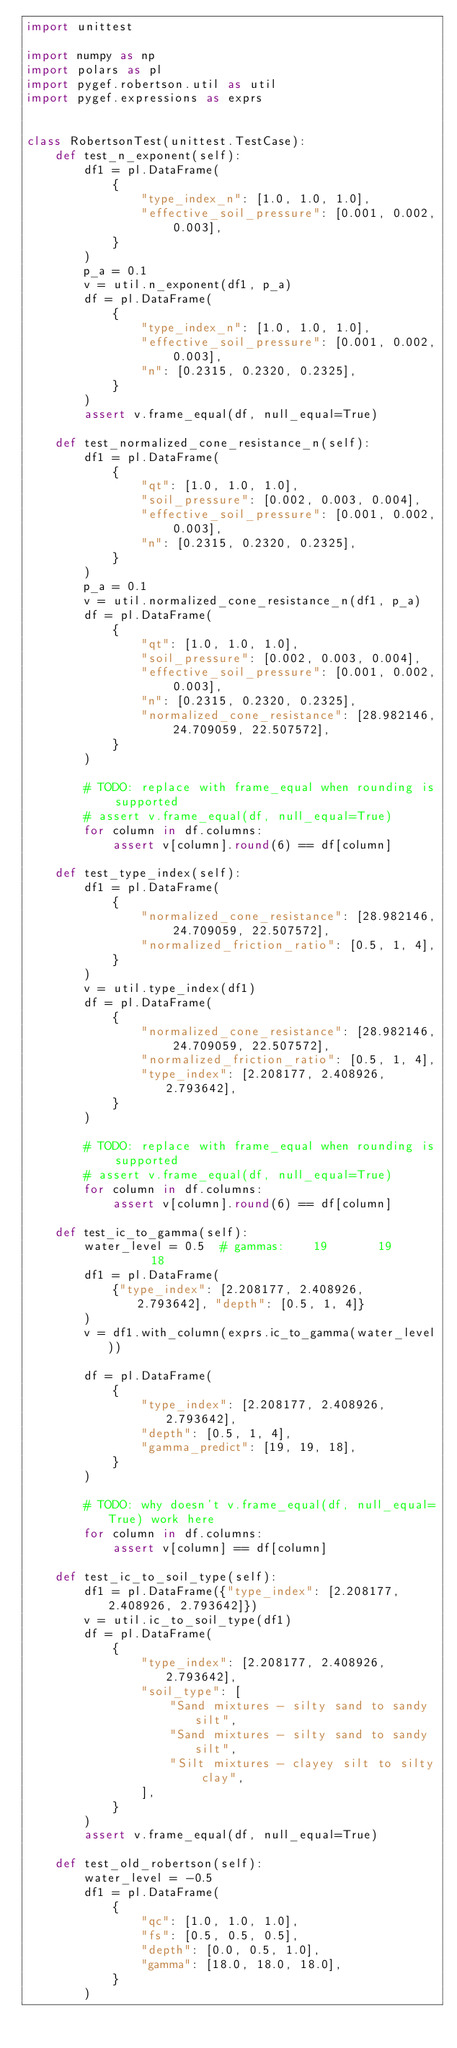Convert code to text. <code><loc_0><loc_0><loc_500><loc_500><_Python_>import unittest

import numpy as np
import polars as pl
import pygef.robertson.util as util
import pygef.expressions as exprs


class RobertsonTest(unittest.TestCase):
    def test_n_exponent(self):
        df1 = pl.DataFrame(
            {
                "type_index_n": [1.0, 1.0, 1.0],
                "effective_soil_pressure": [0.001, 0.002, 0.003],
            }
        )
        p_a = 0.1
        v = util.n_exponent(df1, p_a)
        df = pl.DataFrame(
            {
                "type_index_n": [1.0, 1.0, 1.0],
                "effective_soil_pressure": [0.001, 0.002, 0.003],
                "n": [0.2315, 0.2320, 0.2325],
            }
        )
        assert v.frame_equal(df, null_equal=True)

    def test_normalized_cone_resistance_n(self):
        df1 = pl.DataFrame(
            {
                "qt": [1.0, 1.0, 1.0],
                "soil_pressure": [0.002, 0.003, 0.004],
                "effective_soil_pressure": [0.001, 0.002, 0.003],
                "n": [0.2315, 0.2320, 0.2325],
            }
        )
        p_a = 0.1
        v = util.normalized_cone_resistance_n(df1, p_a)
        df = pl.DataFrame(
            {
                "qt": [1.0, 1.0, 1.0],
                "soil_pressure": [0.002, 0.003, 0.004],
                "effective_soil_pressure": [0.001, 0.002, 0.003],
                "n": [0.2315, 0.2320, 0.2325],
                "normalized_cone_resistance": [28.982146, 24.709059, 22.507572],
            }
        )

        # TODO: replace with frame_equal when rounding is supported
        # assert v.frame_equal(df, null_equal=True)
        for column in df.columns:
            assert v[column].round(6) == df[column]

    def test_type_index(self):
        df1 = pl.DataFrame(
            {
                "normalized_cone_resistance": [28.982146, 24.709059, 22.507572],
                "normalized_friction_ratio": [0.5, 1, 4],
            }
        )
        v = util.type_index(df1)
        df = pl.DataFrame(
            {
                "normalized_cone_resistance": [28.982146, 24.709059, 22.507572],
                "normalized_friction_ratio": [0.5, 1, 4],
                "type_index": [2.208177, 2.408926, 2.793642],
            }
        )

        # TODO: replace with frame_equal when rounding is supported
        # assert v.frame_equal(df, null_equal=True)
        for column in df.columns:
            assert v[column].round(6) == df[column]

    def test_ic_to_gamma(self):
        water_level = 0.5  # gammas:    19       19       18
        df1 = pl.DataFrame(
            {"type_index": [2.208177, 2.408926, 2.793642], "depth": [0.5, 1, 4]}
        )
        v = df1.with_column(exprs.ic_to_gamma(water_level))

        df = pl.DataFrame(
            {
                "type_index": [2.208177, 2.408926, 2.793642],
                "depth": [0.5, 1, 4],
                "gamma_predict": [19, 19, 18],
            }
        )

        # TODO: why doesn't v.frame_equal(df, null_equal=True) work here
        for column in df.columns:
            assert v[column] == df[column]

    def test_ic_to_soil_type(self):
        df1 = pl.DataFrame({"type_index": [2.208177, 2.408926, 2.793642]})
        v = util.ic_to_soil_type(df1)
        df = pl.DataFrame(
            {
                "type_index": [2.208177, 2.408926, 2.793642],
                "soil_type": [
                    "Sand mixtures - silty sand to sandy silt",
                    "Sand mixtures - silty sand to sandy silt",
                    "Silt mixtures - clayey silt to silty clay",
                ],
            }
        )
        assert v.frame_equal(df, null_equal=True)

    def test_old_robertson(self):
        water_level = -0.5
        df1 = pl.DataFrame(
            {
                "qc": [1.0, 1.0, 1.0],
                "fs": [0.5, 0.5, 0.5],
                "depth": [0.0, 0.5, 1.0],
                "gamma": [18.0, 18.0, 18.0],
            }
        )</code> 